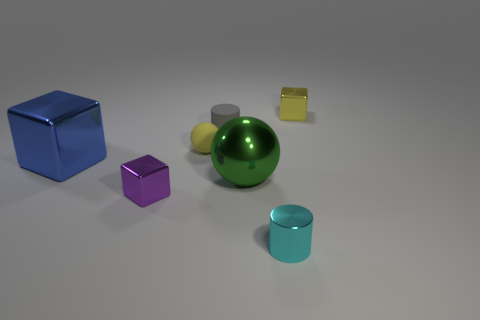What is the shape of the purple object that is the same size as the gray object?
Your answer should be very brief. Cube. Is there anything else of the same color as the large sphere?
Offer a terse response. No. There is a green ball that is made of the same material as the big blue cube; what size is it?
Make the answer very short. Large. Do the small cyan object and the metal thing behind the blue metal object have the same shape?
Your response must be concise. No. The blue shiny block is what size?
Make the answer very short. Large. Are there fewer rubber cylinders that are on the left side of the small purple shiny block than small yellow metallic cylinders?
Offer a very short reply. No. How many green metallic things have the same size as the blue thing?
Your answer should be compact. 1. There is a small shiny object that is the same color as the tiny rubber ball; what is its shape?
Your answer should be very brief. Cube. There is a shiny cube that is on the right side of the tiny metallic cylinder; is its color the same as the ball that is on the left side of the gray object?
Give a very brief answer. Yes. How many shiny cylinders are right of the small matte ball?
Provide a short and direct response. 1. 